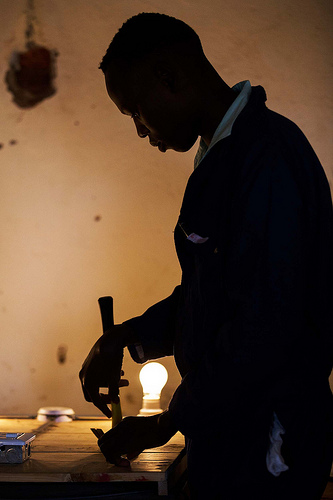<image>
Can you confirm if the man is behind the table? No. The man is not behind the table. From this viewpoint, the man appears to be positioned elsewhere in the scene. 